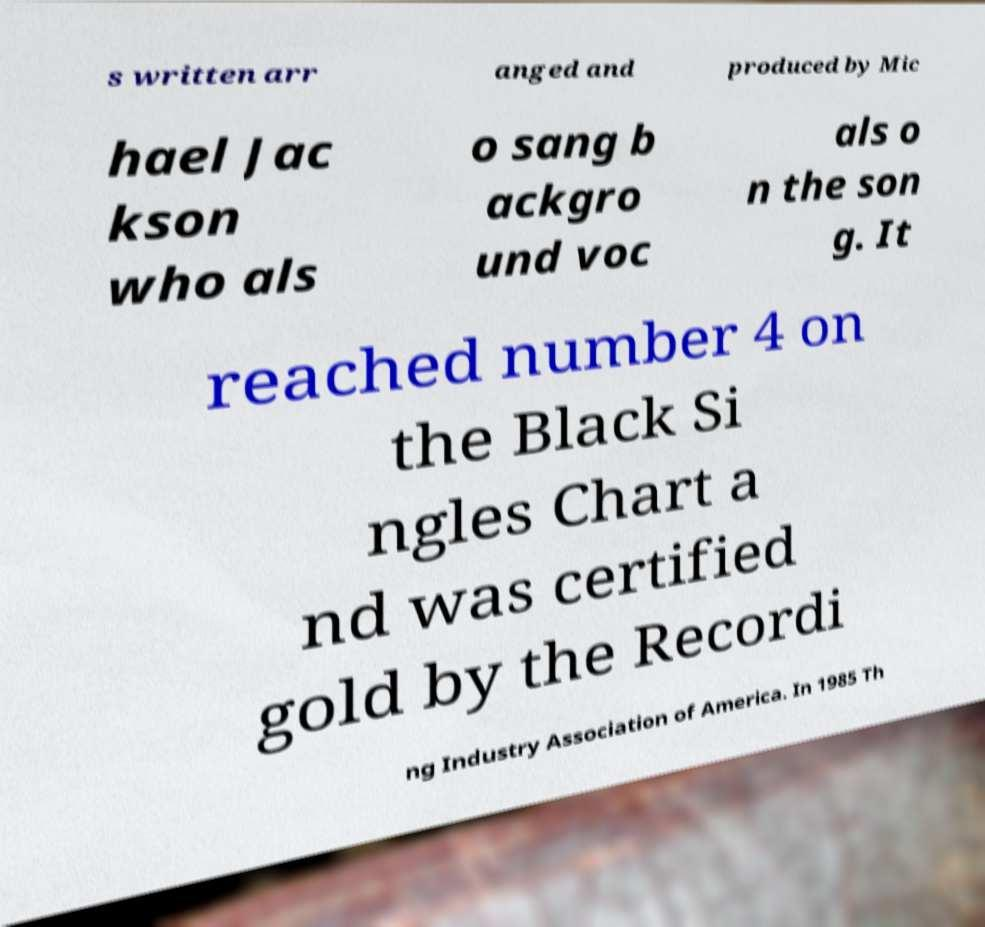Could you assist in decoding the text presented in this image and type it out clearly? s written arr anged and produced by Mic hael Jac kson who als o sang b ackgro und voc als o n the son g. It reached number 4 on the Black Si ngles Chart a nd was certified gold by the Recordi ng Industry Association of America. In 1985 Th 